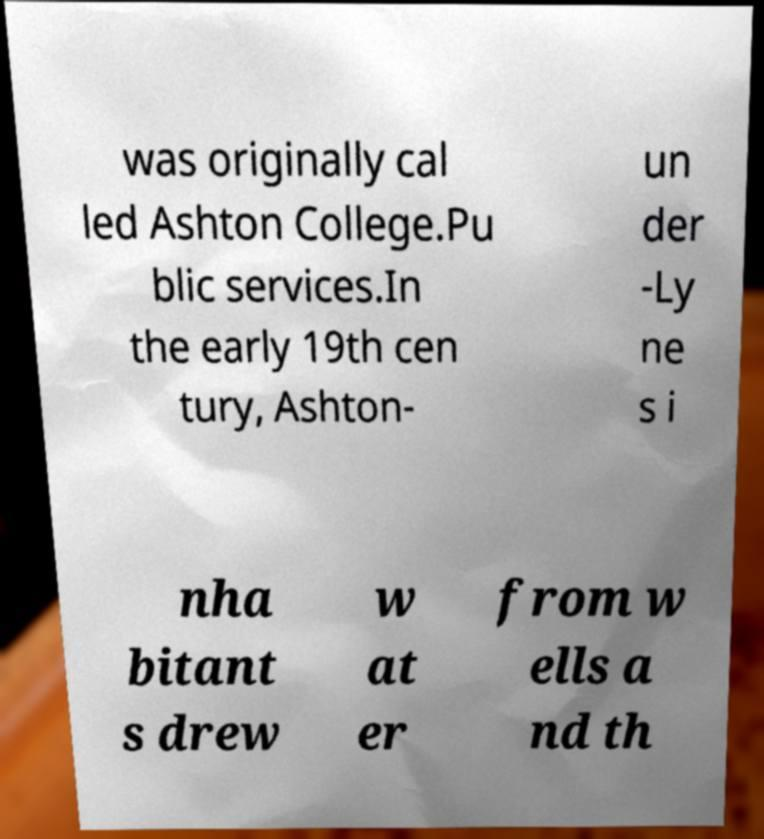Can you read and provide the text displayed in the image?This photo seems to have some interesting text. Can you extract and type it out for me? was originally cal led Ashton College.Pu blic services.In the early 19th cen tury, Ashton- un der -Ly ne s i nha bitant s drew w at er from w ells a nd th 